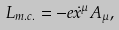<formula> <loc_0><loc_0><loc_500><loc_500>L _ { m . c . } = - e \dot { x } ^ { \mu } A _ { \mu } ,</formula> 